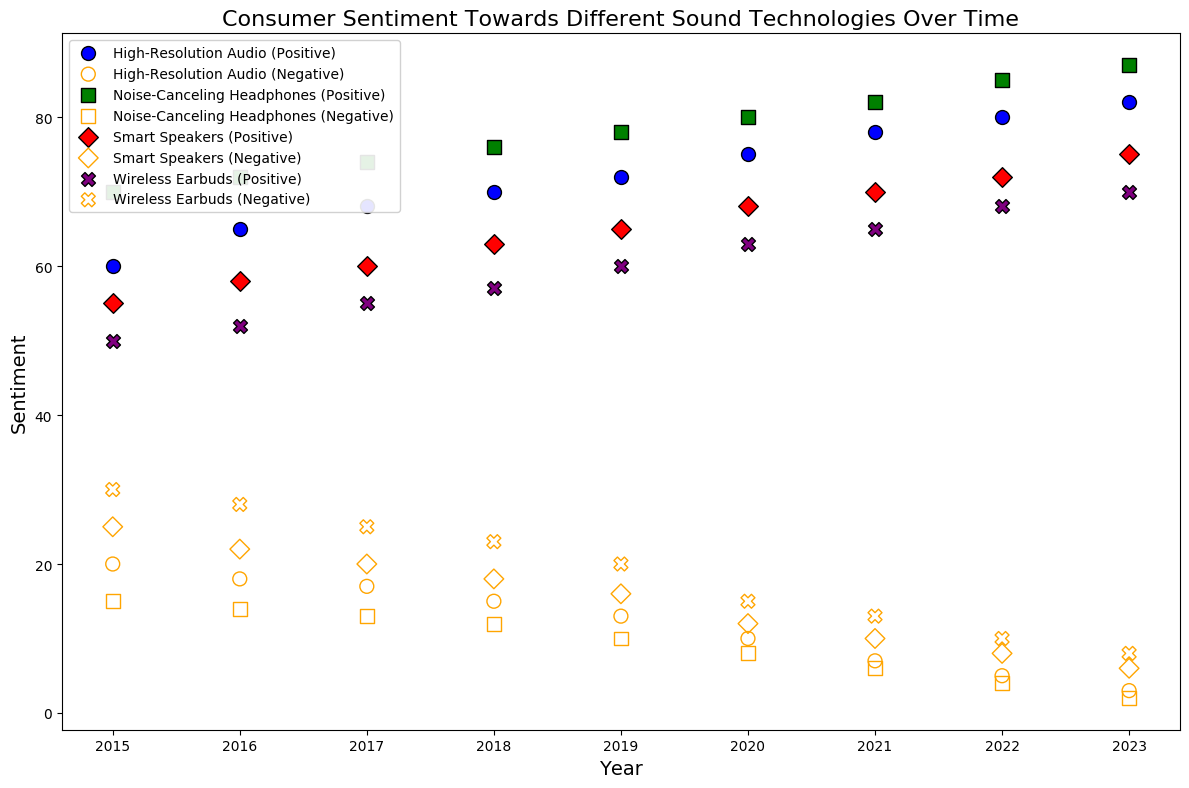What is the trend of positive sentiment for Noise-Canceling Headphones from 2015 to 2023? The figure shows the positive sentiment for Noise-Canceling Headphones increasing every year, starting from 70 in 2015 to 87 in 2023
Answer: Positive sentiment is increasing Which sound technology showed the highest positive sentiment in 2017? By examining the plot, Noise-Canceling Headphones had the highest positive sentiment in 2017 with a value of 74
Answer: Noise-Canceling Headphones How does the negative sentiment of Smart Speakers compare to Wireless Earbuds in 2023? In 2023, the plot shows Smart Speakers with a negative sentiment of 6 and Wireless Earbuds with a negative sentiment of 8. Since 6 is less than 8, Smart Speakers have a lower negative sentiment
Answer: Smart Speakers have lower negative sentiment What is the average positive sentiment for High-Resolution Audio over the years 2018 to 2023? First, we find the positive sentiments: 70 (2018), 72 (2019), 75 (2020), 78 (2021), 80 (2022), and 82 (2023). Sum these values: 70 + 72 + 75 + 78 + 80 + 82 = 457. Divide by the number of years: 457 / 6 = 76.17
Answer: 76.17 Compare the increase in positive sentiment for Wireless Earbuds from 2016 to 2023 with that of Smart Speakers over the same period Wireless Earbuds' positive sentiment increased from 52 to 70 (a rise of 18), while Smart Speakers' positive sentiment increased from 58 to 75 (a rise of 17). Therefore, Wireless Earbuds had a slightly higher increase
Answer: Wireless Earbuds had a higher increase What is the trend in negative sentiment for High-Resolution Audio from 2018 to 2023? The plot indicates a decrease in negative sentiment for High-Resolution Audio each year, starting from 15 in 2018 to 3 in 2023
Answer: Negative sentiment is decreasing Which sound technology shows the most noticeable improvement in positive sentiment from 2015 to 2020? In 2015, Noise-Canceling Headphones had a 70 positive sentiment, and in 2020 it reached 80. This is the highest increase (10 points) compared to other technologies over the same period
Answer: Noise-Canceling Headphones Compare the negative sentiment for Smart Speakers and Noise-Canceling Headphones in 2020 and describe the difference In 2020, Smart Speakers had a negative sentiment of 12 while Noise-Canceling Headphones had 8. Smart Speakers have 4 points higher negative sentiment than Noise-Canceling Headphones
Answer: Smart Speakers have higher negative sentiment What is the cumulative positive sentiment for Wireless Earbuds in 2015 and 2023? Add the positive sentiments for Wireless Earbuds in 2015 (50) and 2023 (70): 50 + 70 = 120
Answer: 120 Which sound technology had the lowest negative sentiment in any year according to the plot? Observing the plot, Noise-Canceling Headphones had the lowest negative sentiment of 2 in 2023
Answer: Noise-Canceling Headphones 